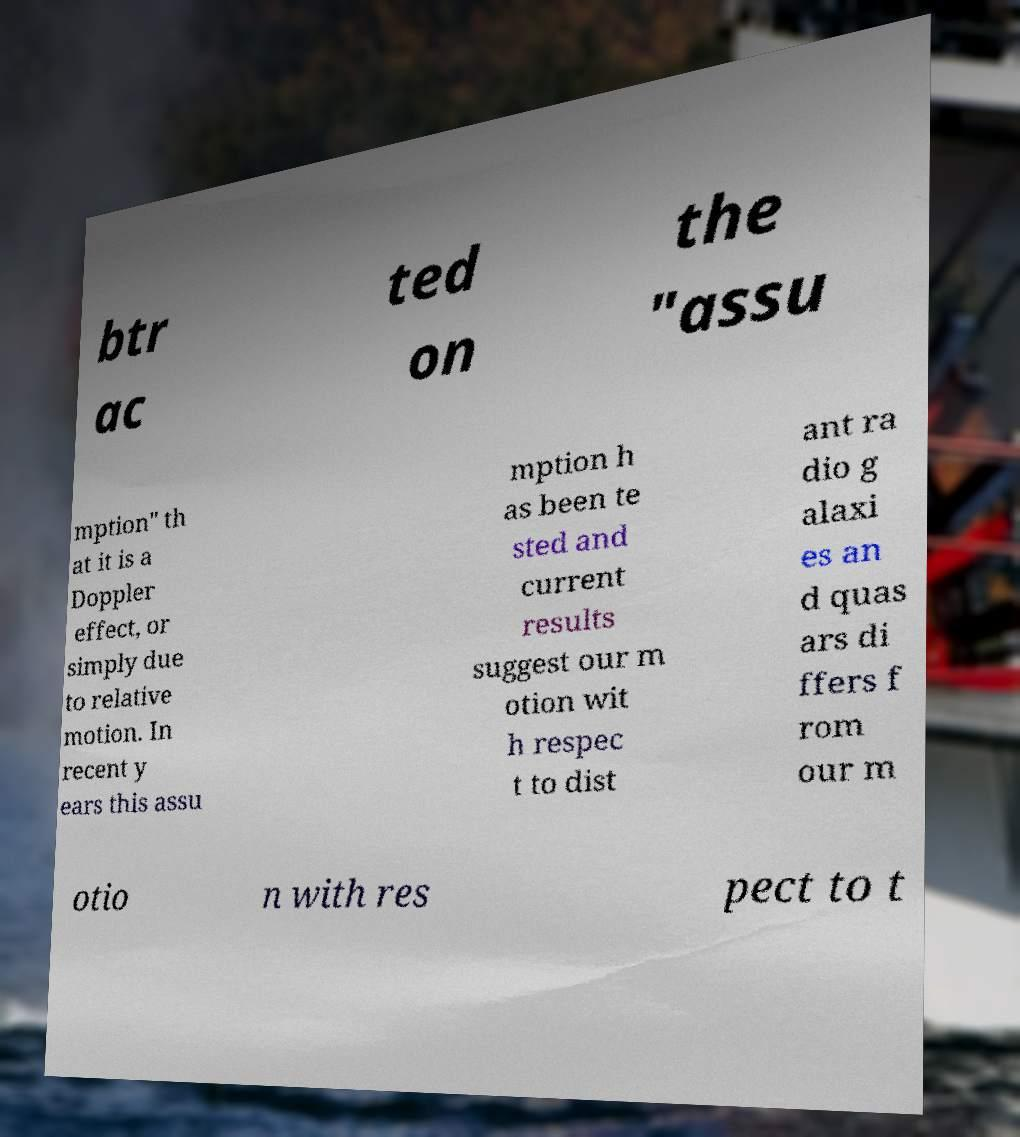I need the written content from this picture converted into text. Can you do that? btr ac ted on the "assu mption" th at it is a Doppler effect, or simply due to relative motion. In recent y ears this assu mption h as been te sted and current results suggest our m otion wit h respec t to dist ant ra dio g alaxi es an d quas ars di ffers f rom our m otio n with res pect to t 